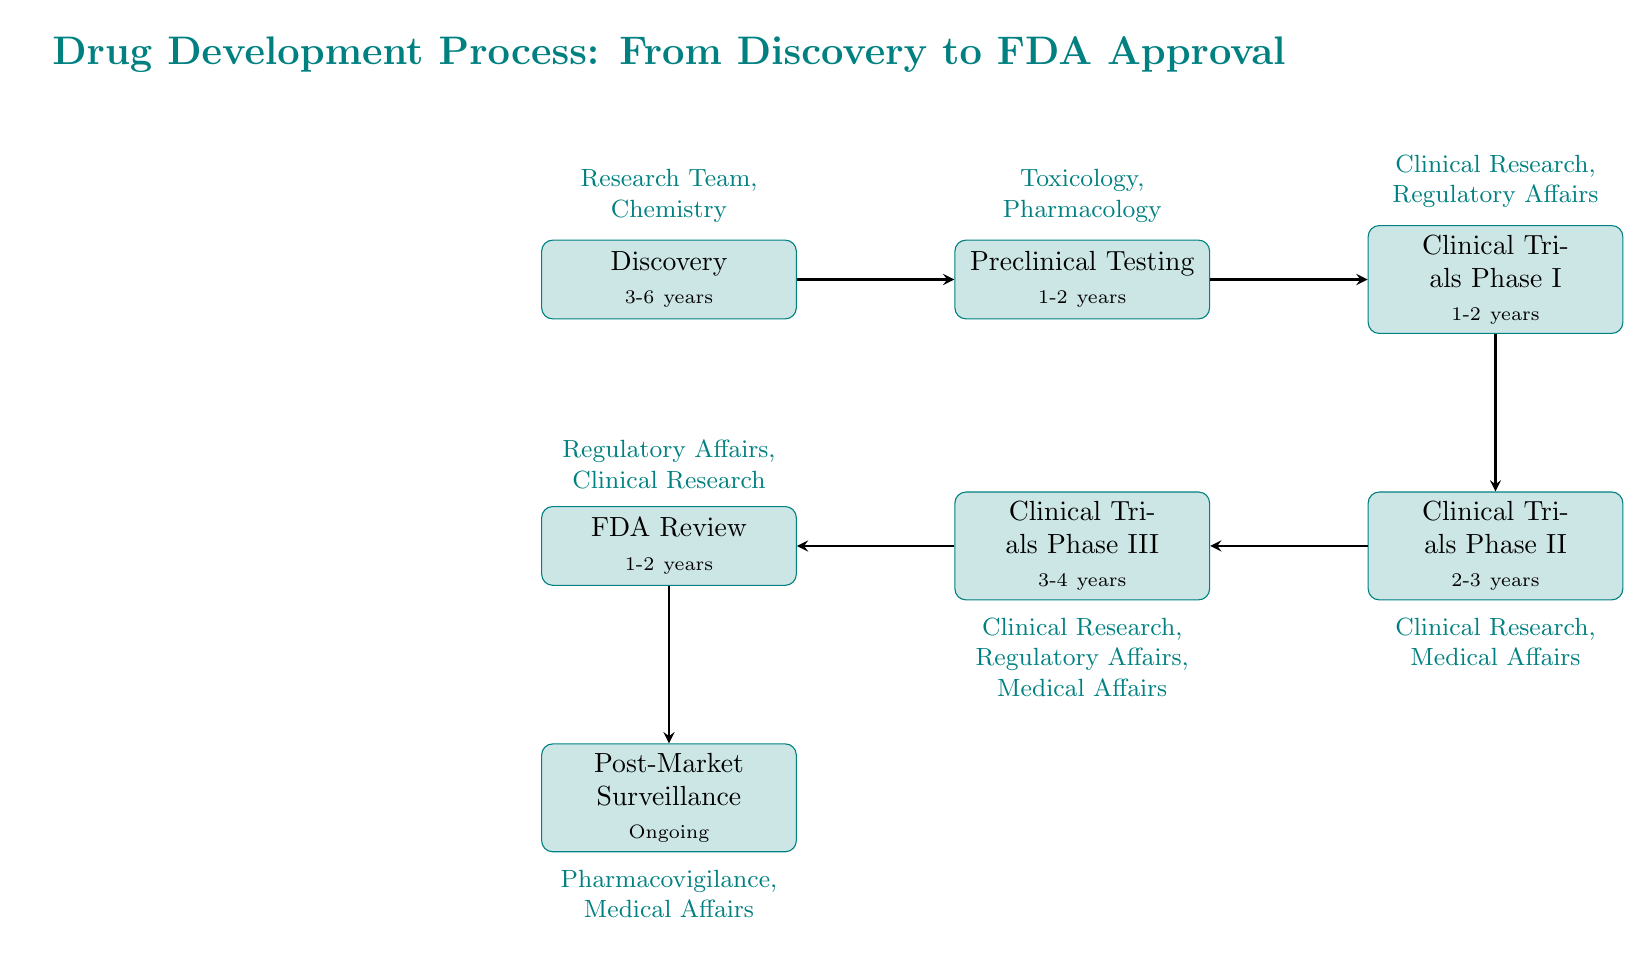What is the duration of the Discovery phase? The Discovery phase in the diagram indicates a duration of "3-6 years". This information is directly stated within the node representing the Discovery phase.
Answer: 3-6 years Which department is involved in the Clinical Trials Phase I? The Clinical Trials Phase I node specifies that "Clinical Research" and "Regulatory Affairs" are involved. This is shown in the department section of that node.
Answer: Clinical Research, Regulatory Affairs How many phases are there in Clinical Trials? The diagram shows three distinct phases under Clinical Trials: Phase I, Phase II, and Phase III. By counting the nodes associated with Clinical Trials, the total is three.
Answer: 3 What step follows Preclinical Testing? According to the flow of the diagram, the arrow leading from the Preclinical Testing node points to the Clinical Trials Phase I node. This indicates that Clinical Trials Phase I is the next step in the process.
Answer: Clinical Trials Phase I Which node comes before the FDA Review in the process? The FDA Review node follows the Clinical Trials Phase III node, as indicated by the arrow connecting these two nodes. This means Clinical Trials Phase III is the step prior to FDA Review.
Answer: Clinical Trials Phase III How long do clinical trials take in total (Phases I, II, and III)? Adding the durations of Clinical Trials Phase I (1-2 years), Phase II (2-3 years), and Phase III (3-4 years), we find the total ranges from 6 to 9 years collectively for these phases.
Answer: 6-9 years What departments are involved in Post-Market Surveillance? The node for Post-Market Surveillance indicates involvement from the "Pharmacovigilance" and "Medical Affairs" departments. This provides specific information about the responsibilities after a drug is approved.
Answer: Pharmacovigilance, Medical Affairs What is the relationship between Discovery and Preclinical Testing? The diagram shows an arrow from the Discovery node to the Preclinical Testing node, indicating a direct flow from Discovery to Preclinical Testing as the subsequent step in the process.
Answer: Direct flow What ongoing activities are part of Post-Market Surveillance? The diagram describes Post-Market Surveillance as including "ongoing monitoring of the drug's performance in the general population" which encompasses "pharmacovigilance activities". This detail highlights the continuous nature of post-market surveillance efforts.
Answer: Ongoing monitoring, pharmacovigilance activities 